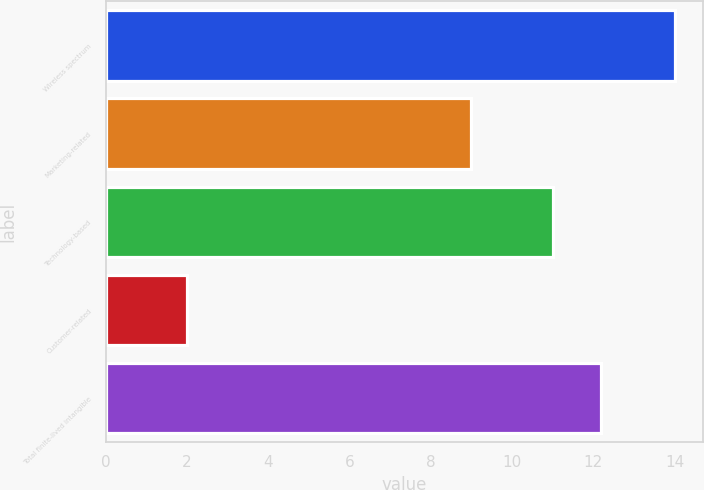Convert chart. <chart><loc_0><loc_0><loc_500><loc_500><bar_chart><fcel>Wireless spectrum<fcel>Marketing-related<fcel>Technology-based<fcel>Customer-related<fcel>Total finite-lived intangible<nl><fcel>14<fcel>9<fcel>11<fcel>2<fcel>12.2<nl></chart> 